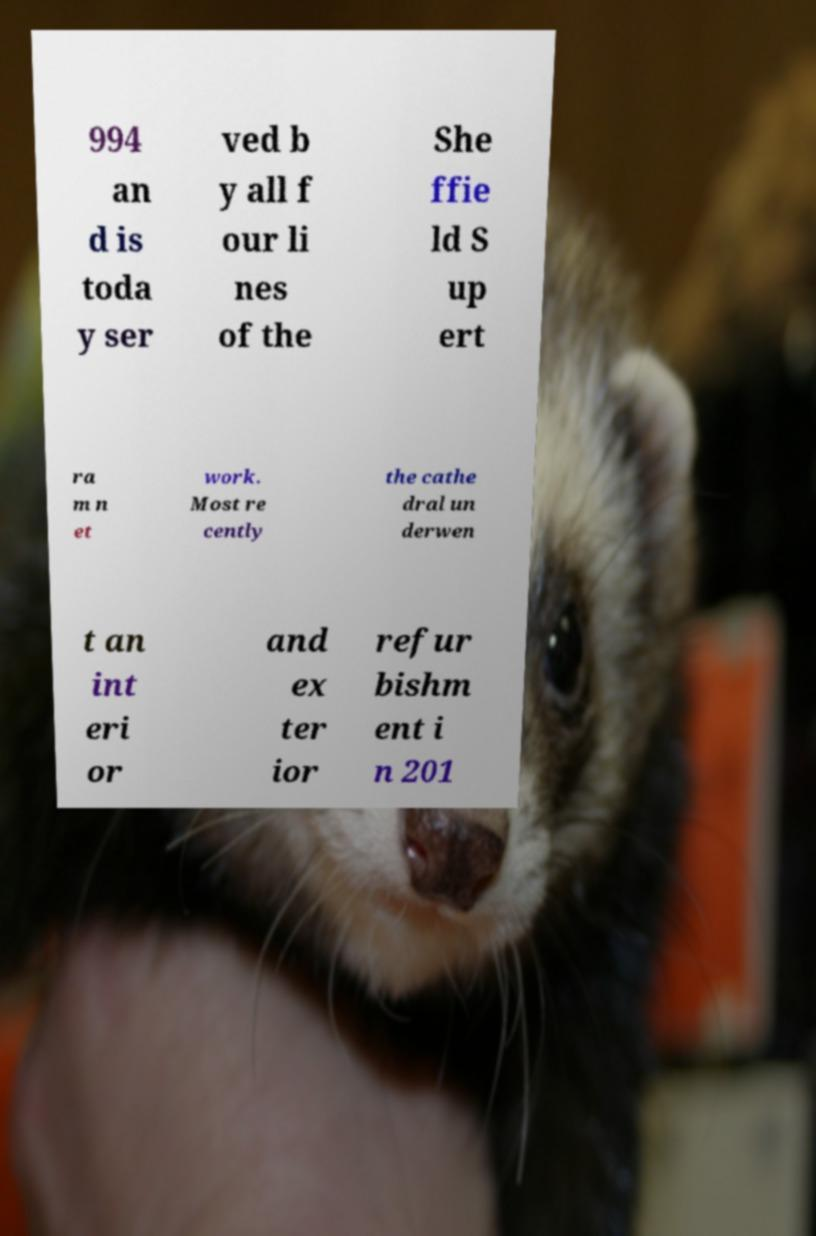For documentation purposes, I need the text within this image transcribed. Could you provide that? 994 an d is toda y ser ved b y all f our li nes of the She ffie ld S up ert ra m n et work. Most re cently the cathe dral un derwen t an int eri or and ex ter ior refur bishm ent i n 201 